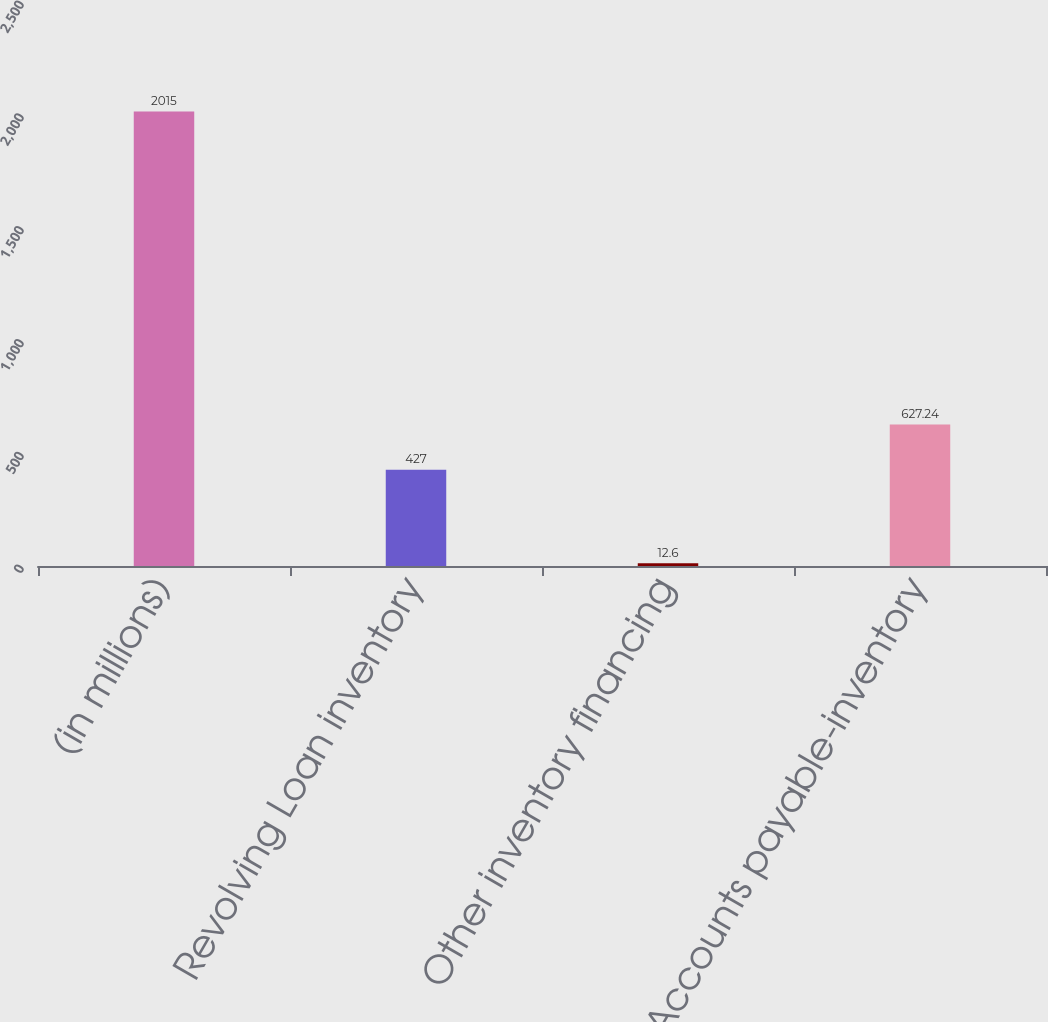<chart> <loc_0><loc_0><loc_500><loc_500><bar_chart><fcel>(in millions)<fcel>Revolving Loan inventory<fcel>Other inventory financing<fcel>Accounts payable-inventory<nl><fcel>2015<fcel>427<fcel>12.6<fcel>627.24<nl></chart> 